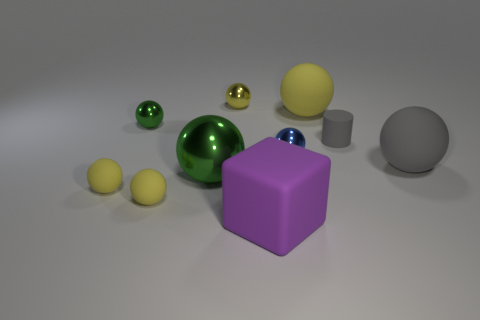I'm curious about the lighting in the image. Can you elaborate on how it affects the appearance of the objects? The overhead lighting casts soft shadows beneath each object, accentuating their shapes and the materials they're made of. It brings out the glossy sheen on the metallic surfaces, highlights the matte texture, and generates subtle reflections on the ground. The lighting plays a significant role in conveying the three-dimensionality and texture diversity in the scene. Does it seem like natural light or artificial light? The evenness and softness of the shadows along with the neutral background suggest it's an artificial light source, quite possibly in a controlled studio environment. There's no indication of direct sunlight or the distinct, harder shadows it would create. 